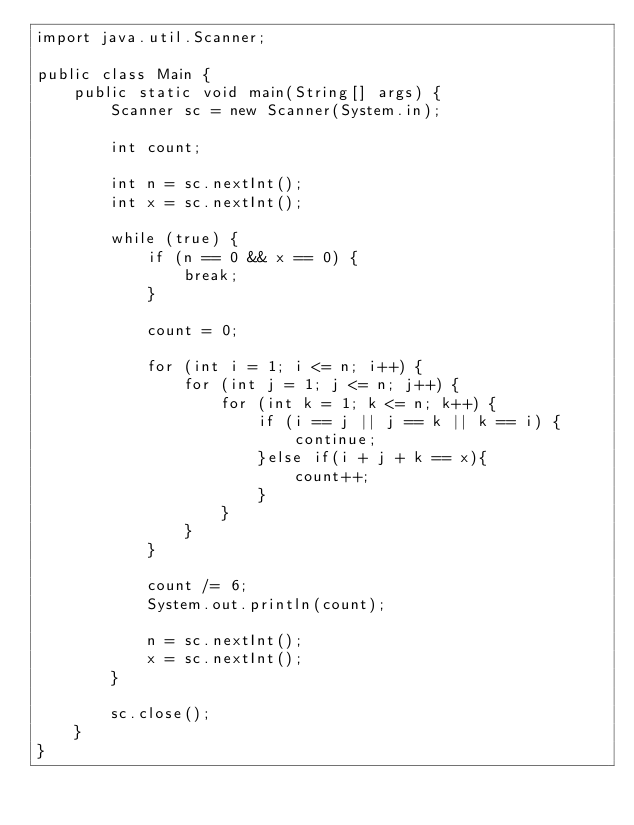Convert code to text. <code><loc_0><loc_0><loc_500><loc_500><_Java_>import java.util.Scanner;

public class Main {
    public static void main(String[] args) {
        Scanner sc = new Scanner(System.in);

        int count;

        int n = sc.nextInt();
        int x = sc.nextInt();

        while (true) {
            if (n == 0 && x == 0) {
                break;
            }

            count = 0;

            for (int i = 1; i <= n; i++) {
                for (int j = 1; j <= n; j++) {
                    for (int k = 1; k <= n; k++) {
                        if (i == j || j == k || k == i) {
                            continue;
                        }else if(i + j + k == x){
                            count++;      
                        }
                    }
                }
            }

            count /= 6;
            System.out.println(count);

            n = sc.nextInt();
            x = sc.nextInt();
        }

        sc.close();
    }
}
</code> 